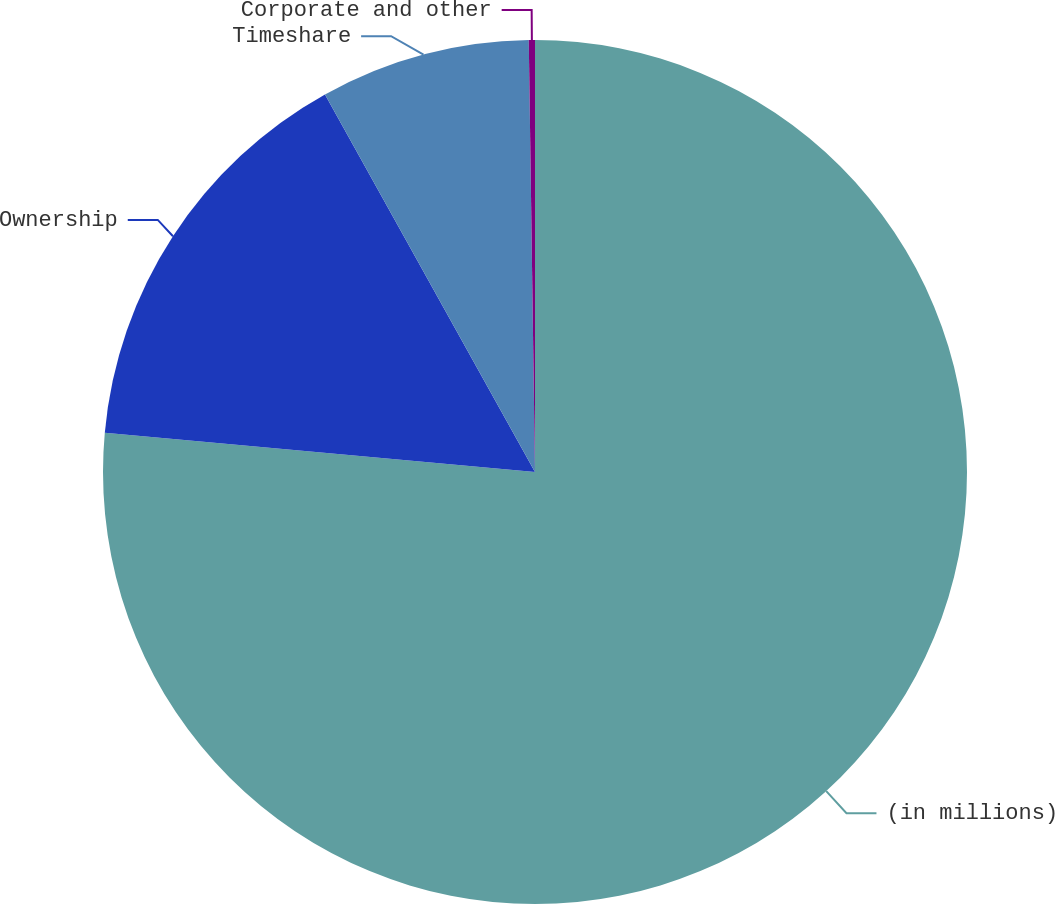Convert chart to OTSL. <chart><loc_0><loc_0><loc_500><loc_500><pie_chart><fcel>(in millions)<fcel>Ownership<fcel>Timeshare<fcel>Corporate and other<nl><fcel>76.45%<fcel>15.47%<fcel>7.85%<fcel>0.23%<nl></chart> 